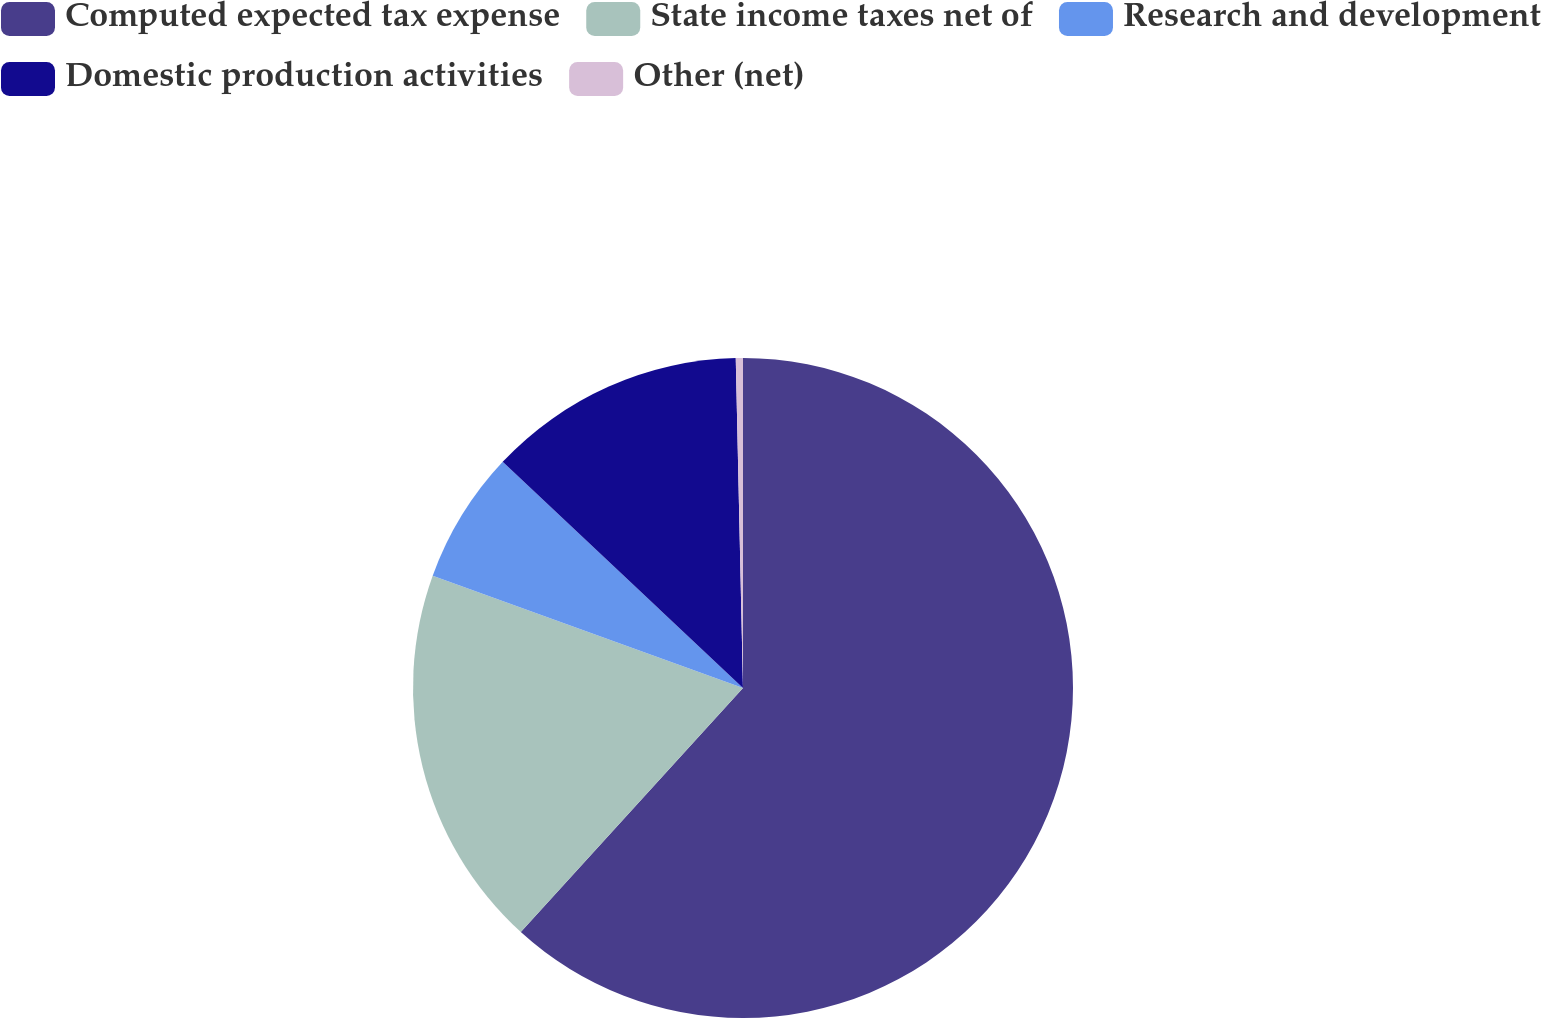Convert chart. <chart><loc_0><loc_0><loc_500><loc_500><pie_chart><fcel>Computed expected tax expense<fcel>State income taxes net of<fcel>Research and development<fcel>Domestic production activities<fcel>Other (net)<nl><fcel>61.75%<fcel>18.77%<fcel>6.49%<fcel>12.63%<fcel>0.35%<nl></chart> 